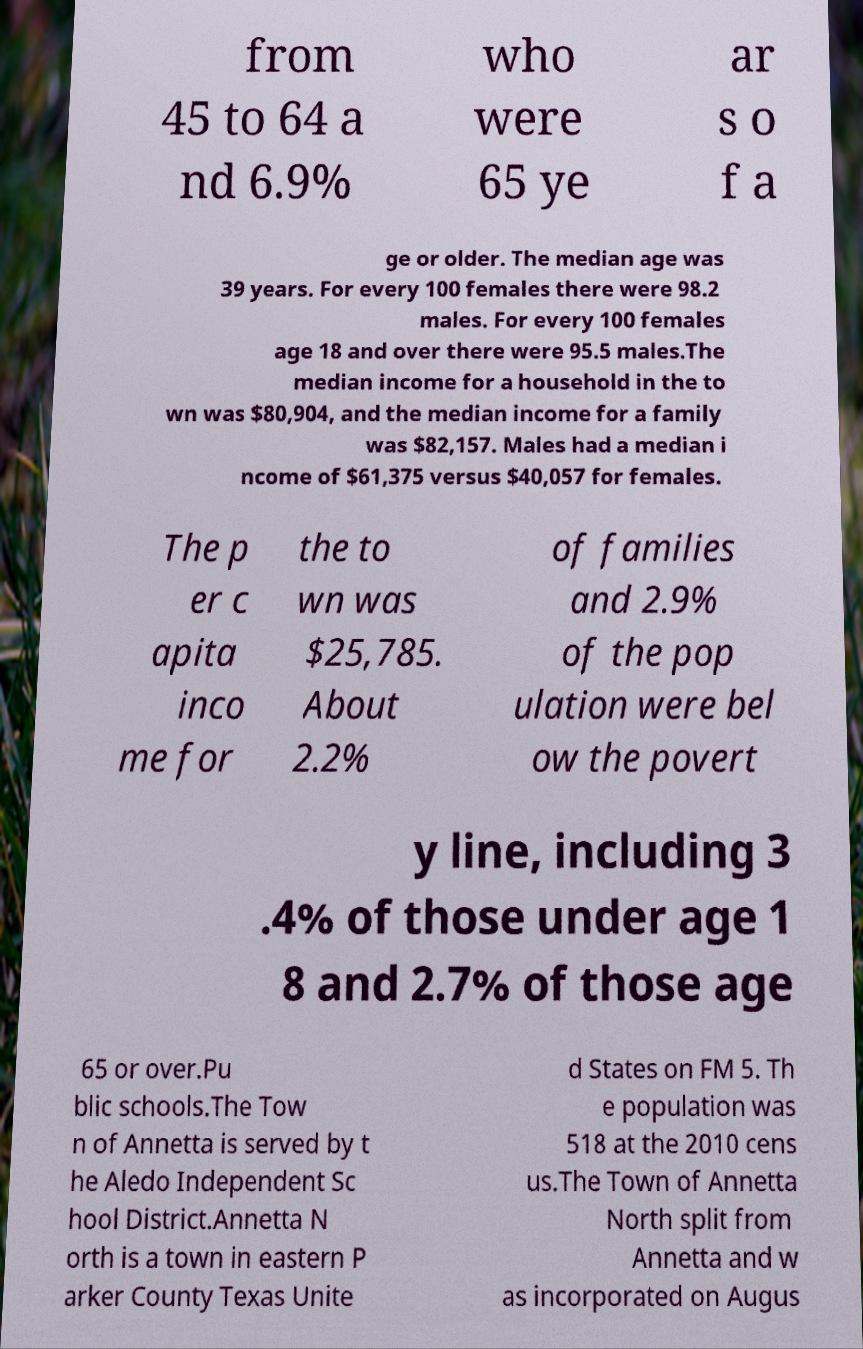Please identify and transcribe the text found in this image. from 45 to 64 a nd 6.9% who were 65 ye ar s o f a ge or older. The median age was 39 years. For every 100 females there were 98.2 males. For every 100 females age 18 and over there were 95.5 males.The median income for a household in the to wn was $80,904, and the median income for a family was $82,157. Males had a median i ncome of $61,375 versus $40,057 for females. The p er c apita inco me for the to wn was $25,785. About 2.2% of families and 2.9% of the pop ulation were bel ow the povert y line, including 3 .4% of those under age 1 8 and 2.7% of those age 65 or over.Pu blic schools.The Tow n of Annetta is served by t he Aledo Independent Sc hool District.Annetta N orth is a town in eastern P arker County Texas Unite d States on FM 5. Th e population was 518 at the 2010 cens us.The Town of Annetta North split from Annetta and w as incorporated on Augus 